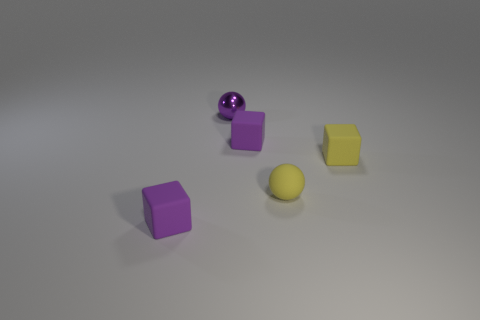There is a rubber thing that is the same color as the rubber sphere; what shape is it?
Provide a short and direct response. Cube. There is a tiny yellow object that is the same shape as the purple metal object; what is its material?
Give a very brief answer. Rubber. The cube that is the same color as the tiny rubber sphere is what size?
Your answer should be compact. Small. Is there another tiny yellow sphere that has the same material as the yellow ball?
Ensure brevity in your answer.  No. Does the object on the left side of the tiny purple sphere have the same color as the metallic object?
Make the answer very short. Yes. What is the size of the purple shiny thing?
Your answer should be compact. Small. There is a small matte cube that is on the right side of the purple rubber thing right of the purple sphere; is there a shiny sphere that is in front of it?
Make the answer very short. No. There is a metallic ball; how many small rubber objects are behind it?
Provide a succinct answer. 0. How many rubber things are the same color as the tiny shiny sphere?
Your answer should be very brief. 2. What number of things are tiny rubber things in front of the rubber ball or blocks that are in front of the yellow rubber cube?
Give a very brief answer. 1. 